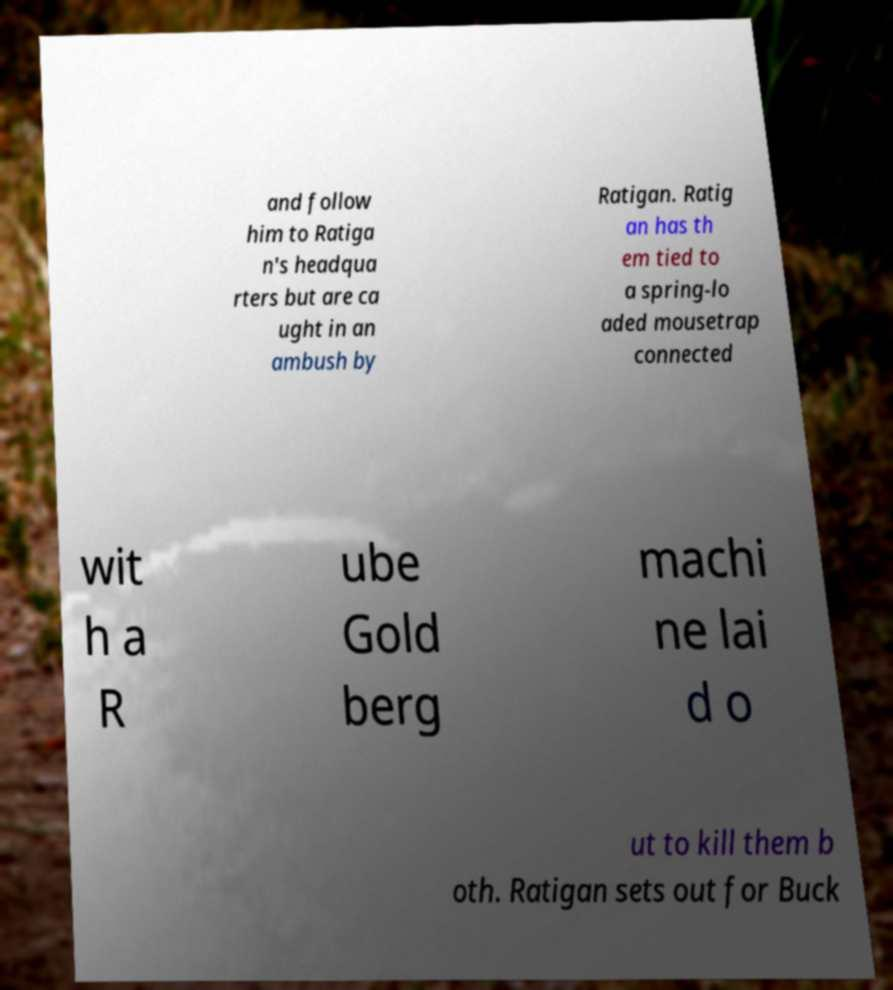Can you accurately transcribe the text from the provided image for me? and follow him to Ratiga n's headqua rters but are ca ught in an ambush by Ratigan. Ratig an has th em tied to a spring-lo aded mousetrap connected wit h a R ube Gold berg machi ne lai d o ut to kill them b oth. Ratigan sets out for Buck 